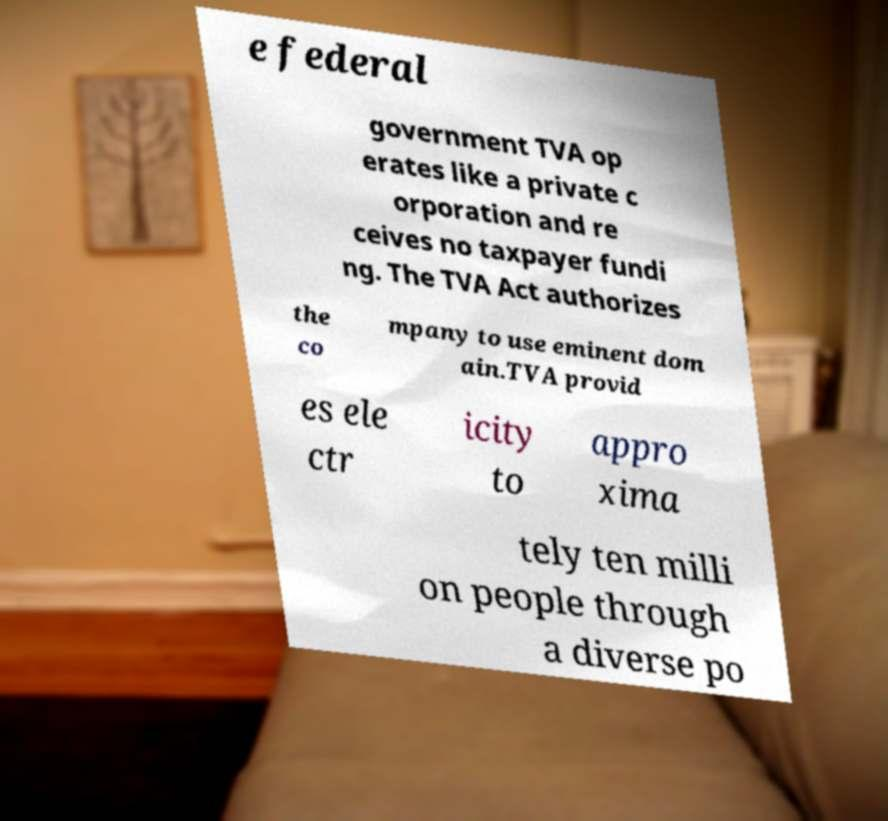Could you assist in decoding the text presented in this image and type it out clearly? e federal government TVA op erates like a private c orporation and re ceives no taxpayer fundi ng. The TVA Act authorizes the co mpany to use eminent dom ain.TVA provid es ele ctr icity to appro xima tely ten milli on people through a diverse po 